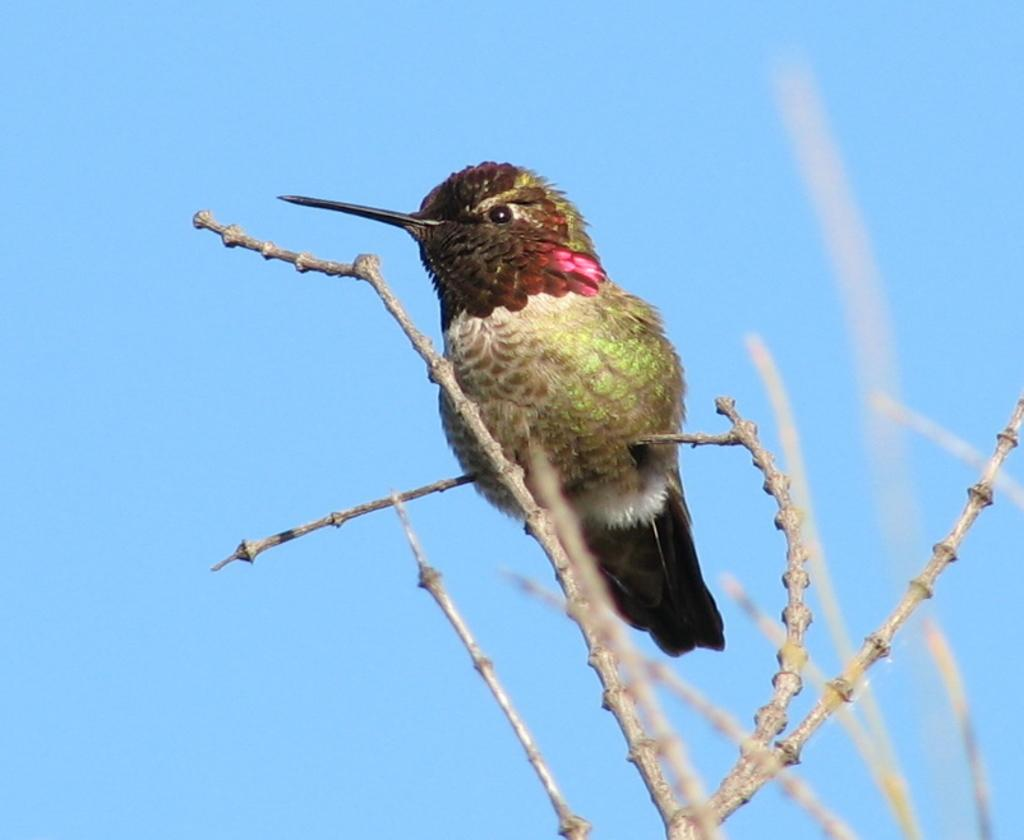What is located in the foreground of the image? There is a bird on a tree in the foreground of the image. What can be seen in the background of the image? The sky is visible in the background of the image. What type of notebook is the bird holding in the image? There is no notebook present in the image; it features a bird on a tree. What color is the bird's tail in the image? There is no mention of a tail in the provided facts, and the image does not show a bird with a visible tail. 